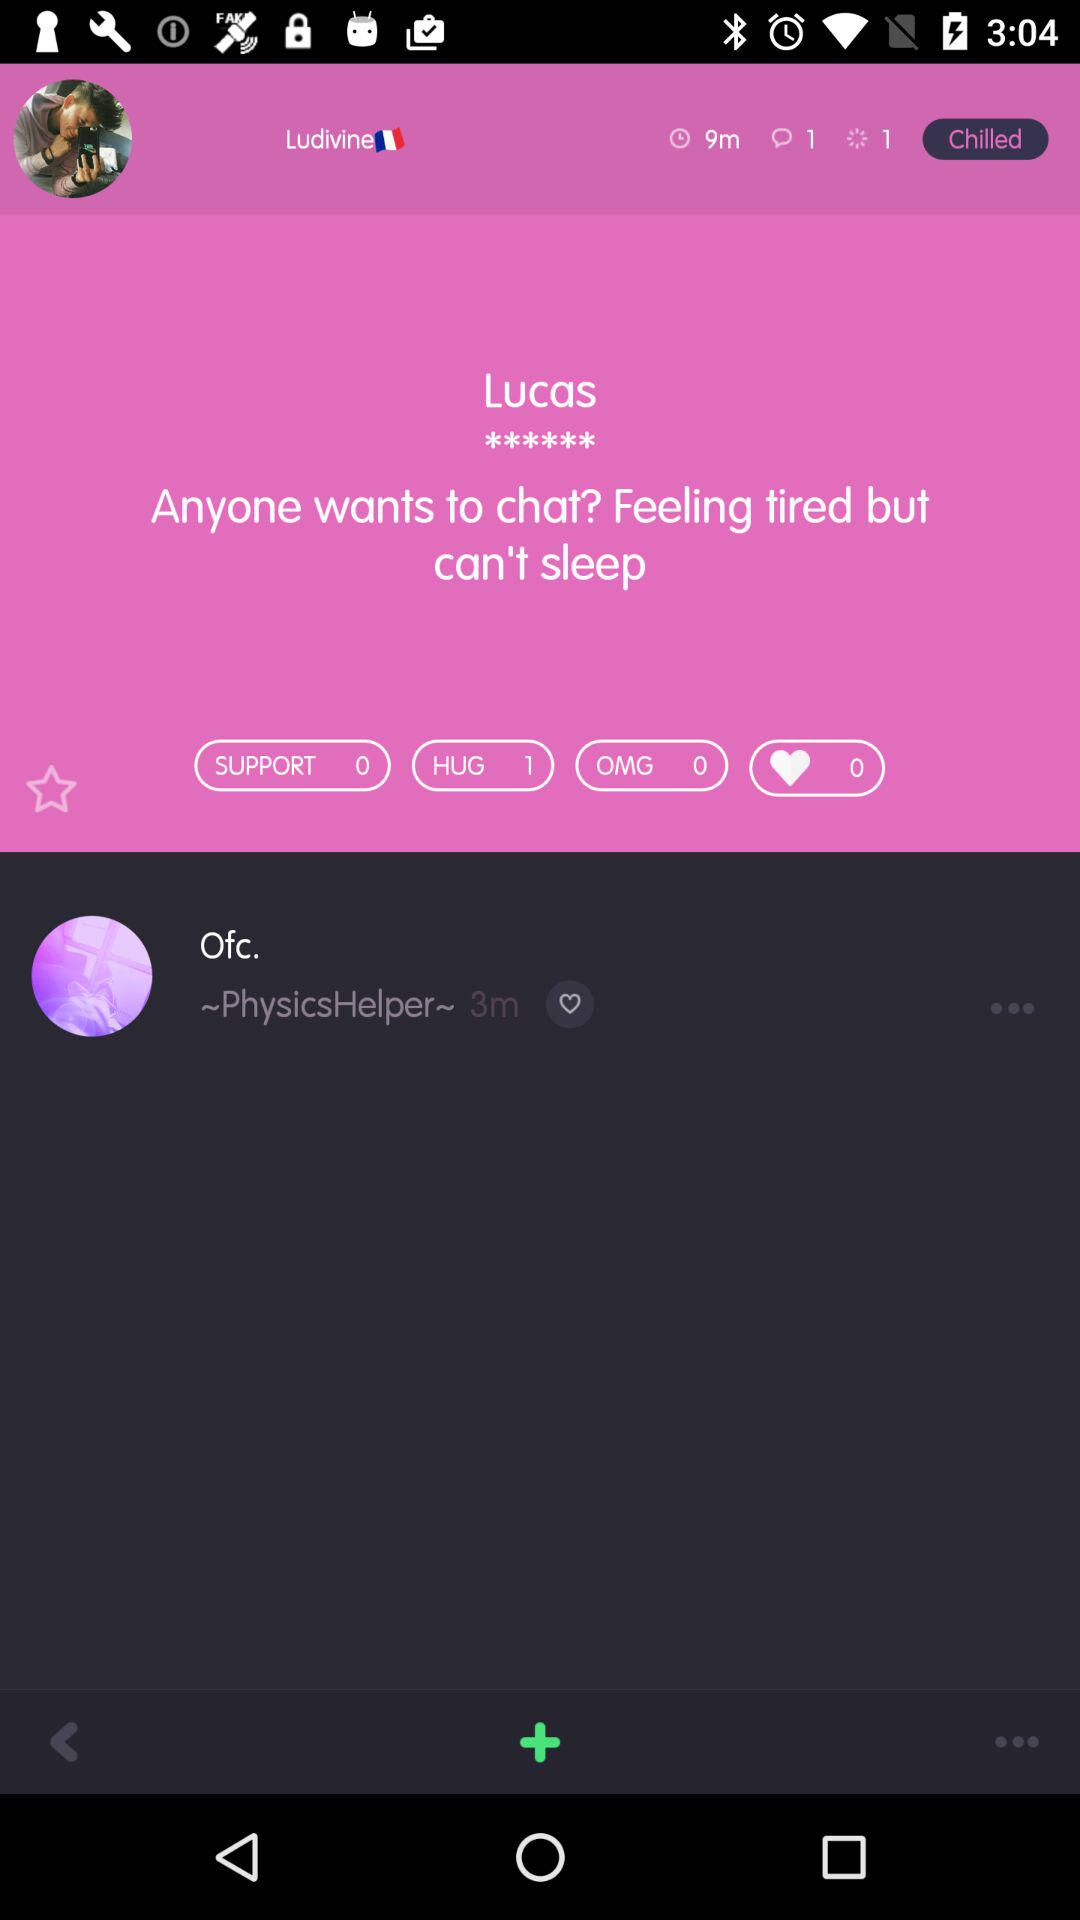How long ago was Ofc. online? Ofc. was online 3 minutes ago. 